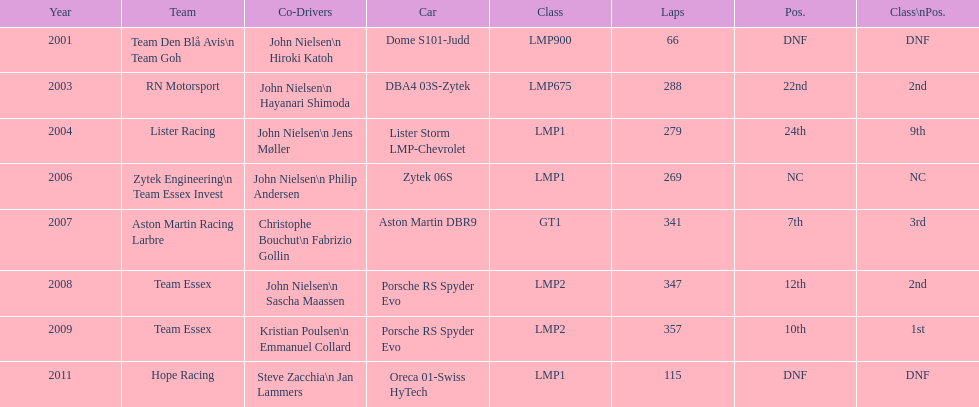Who was casper elgaard's co-driver the most often for the 24 hours of le mans? John Nielsen. 